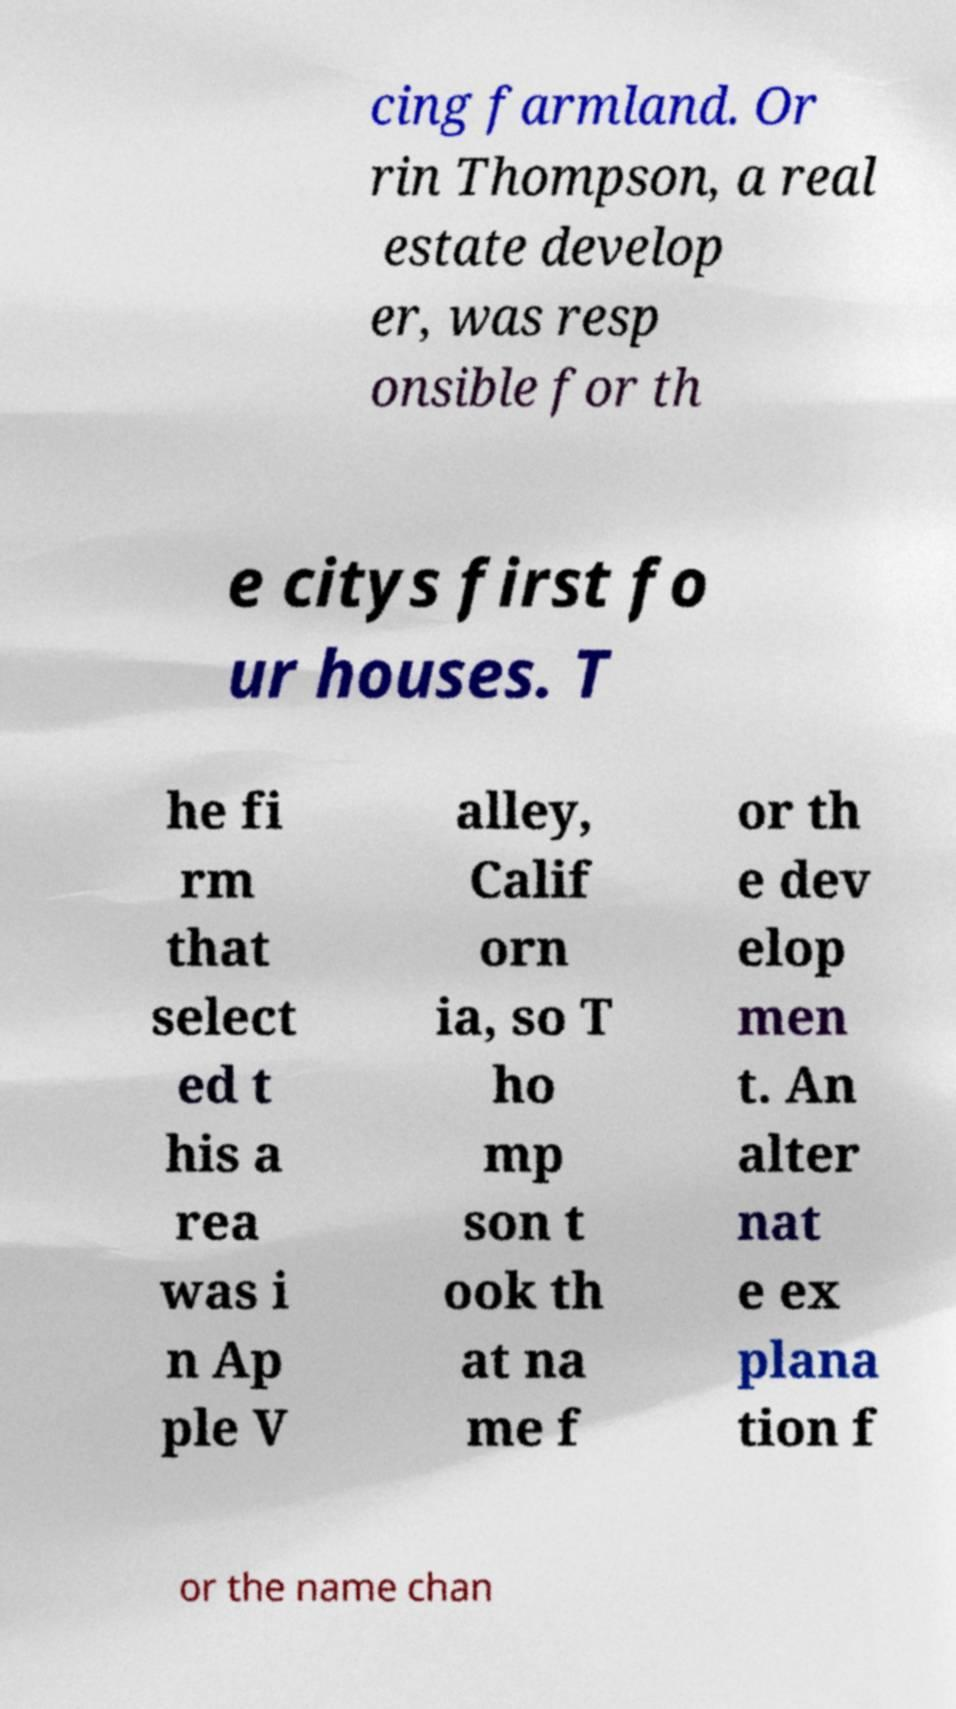There's text embedded in this image that I need extracted. Can you transcribe it verbatim? cing farmland. Or rin Thompson, a real estate develop er, was resp onsible for th e citys first fo ur houses. T he fi rm that select ed t his a rea was i n Ap ple V alley, Calif orn ia, so T ho mp son t ook th at na me f or th e dev elop men t. An alter nat e ex plana tion f or the name chan 